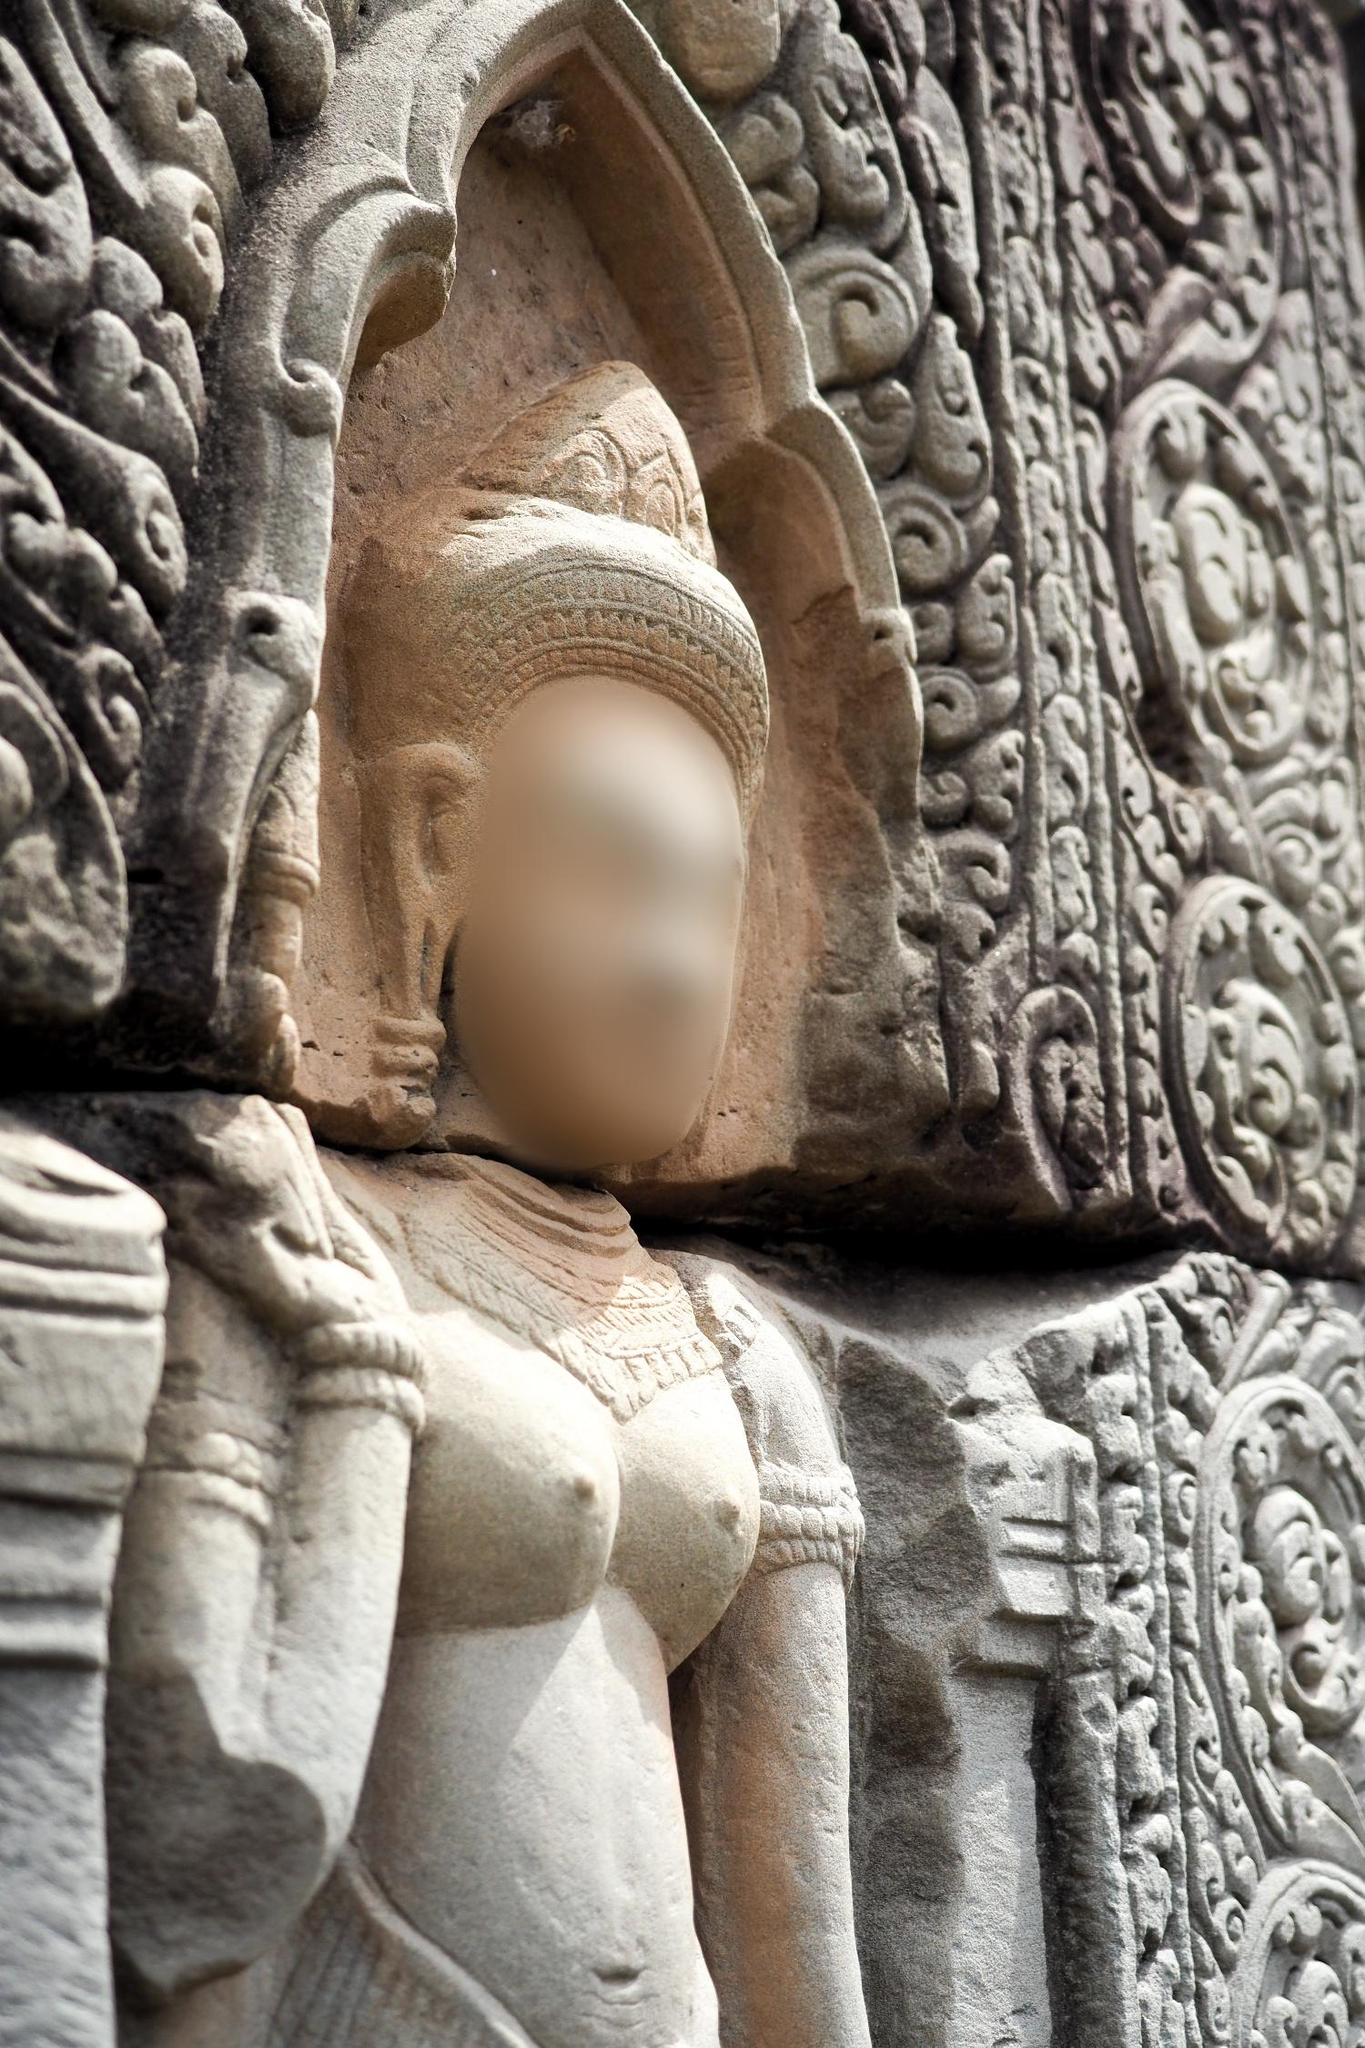Describe how the environment surrounding the statue might look like. The environment surrounding this statue is likely part of a grand, ancient temple or a historical site, possibly enshrouded with greenery and aged stonework. The temple grounds might be adorned with more intricate carvings, towering spires, and sacred symbols. The air perhaps carries the scent of incense and the whispers of wind rustling through the trees. Imagine moss-covered stones, ancient paths tread by countless feet, and the soft murmur of a nearby stream. This setting exudes a serene, yet imposing atmosphere, resonating with the legacy of a time when the divine and mundane intertwined seamlessly, where every stone told a story. How do you think the artisans felt while creating this statue? The artisans likely felt a deep sense of purpose and reverence while creating this statue. Sculpting such a significant piece would have required immense skill, patience, and devotion. They might have experienced a profound connection to their cultural and spiritual heritage, believing their work to be a conduit for divine expression. Each chisel mark could have been a prayer, each detail a homage to their craft and beliefs. Pride in their craftsmanship and a sense of contributing to something eternal would have driven them, knowing their creation would be venerated and cherished for generations to come. Imagine this statue as a character in a fantasy world. How would it come to life and what role would it play? In a fantasy world, this statue could come to life under a moonlit spell, its stone slowly softening into flesh and its blurred face revealing wise, ancient eyes. It could serve as a guardian spirit of the temple, protecting it from dark forces and guiding lost souls to enlightenment. Armed with magical powers derived from centuries of sacred prayers, it might also act as a mentor to a young hero destined to save the realm. Its voice, deep and resonant, would share ancient wisdom and forgotten lore, leading quests to uncover mystical artifacts and confronting forgotten evils. This living statue would be a symbol of timeless wisdom, strength, and the enduring power of history and faith. Based on the craftsmanship, what can you infer about the skills and tools used by the sculptors? The craftsmanship displayed suggests the sculptors were highly skilled artisans, likely trained from a young age in the traditional methods of stone carving. They would have used tools like chisels, mallets, and perhaps rudimentary drills, made from iron or bronze. Their ability to create such detailed and harmonious works indicates a deep understanding of both their material and their cultural or religious subjects. The precision of the carvings suggests they had developed meticulous techniques for smoothing, detailing, and polishing stone. These artisans were not just laborers but masters of an art form passed down through generations, creating works meant to withstand the vast currents of time. 